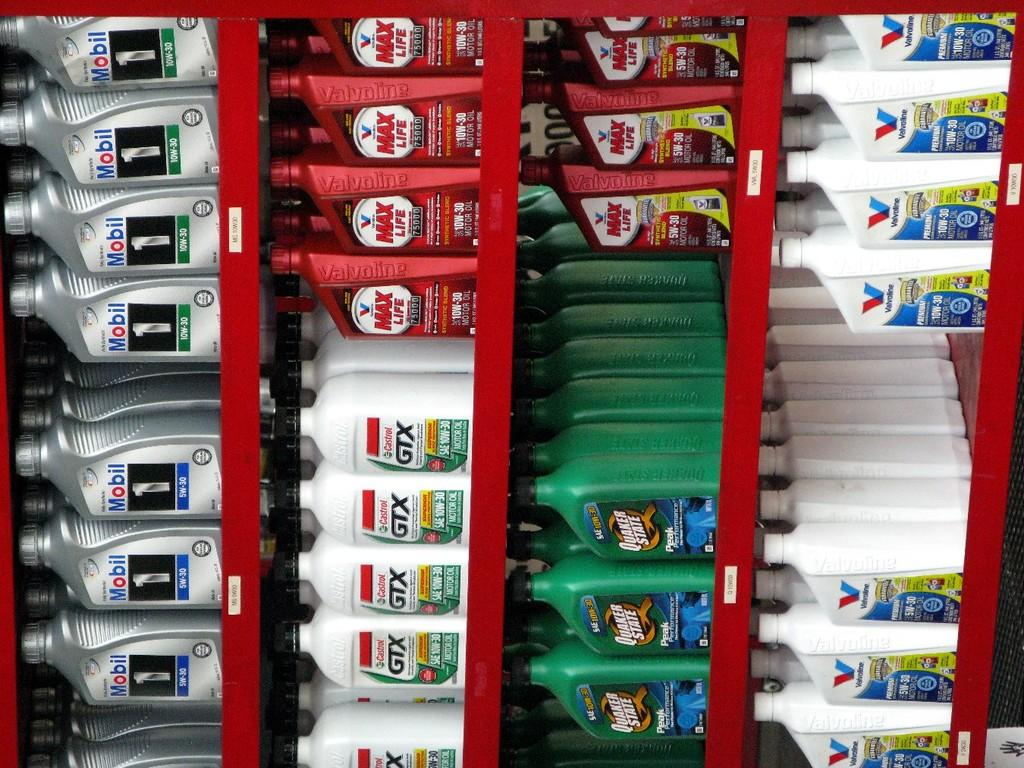Provide a one-sentence caption for the provided image. Line of products for car engine oil including GTX and Mobil. 